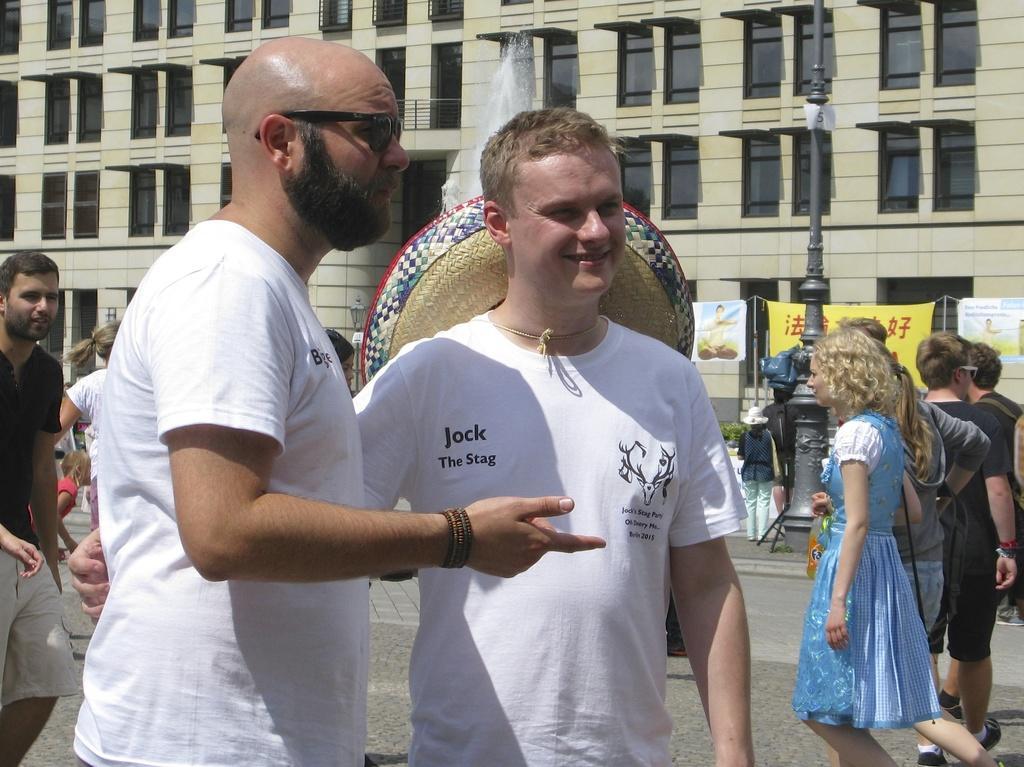Describe this image in one or two sentences. 2 people are standing wearing white t shirt. There are other people at the back. There is a pole, fountain and building at the back. 